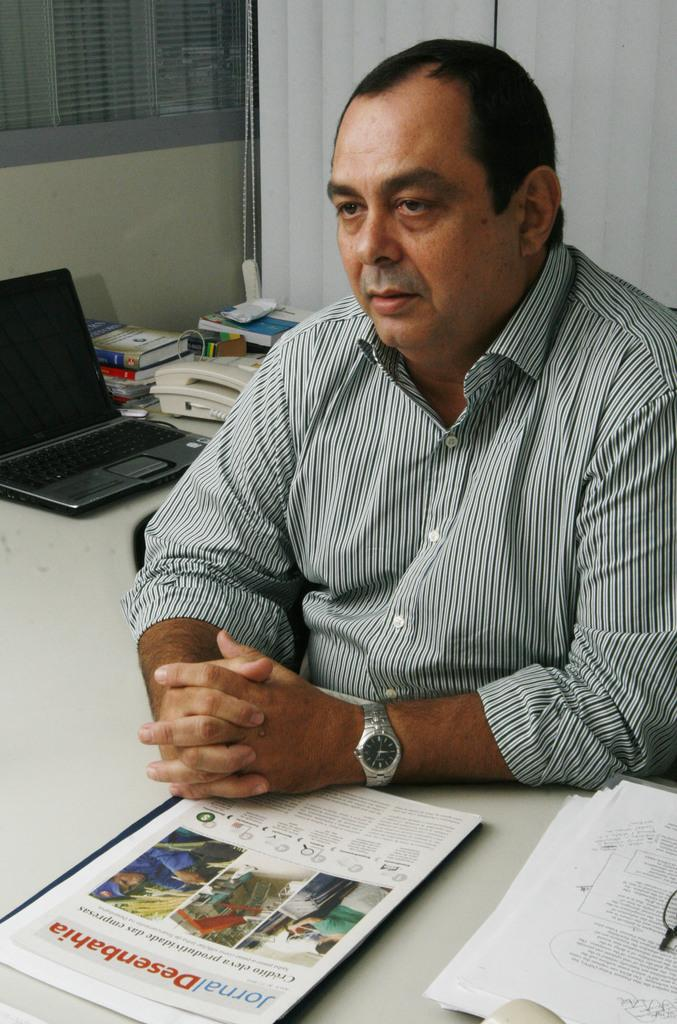<image>
Create a compact narrative representing the image presented. Man with a booklet in front of him that says "Desenbahia". 